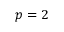<formula> <loc_0><loc_0><loc_500><loc_500>p = 2</formula> 